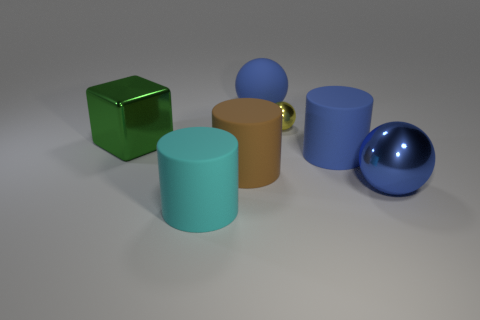Do the small shiny object and the shiny block have the same color?
Provide a succinct answer. No. The large matte object that is the same color as the large rubber sphere is what shape?
Offer a very short reply. Cylinder. What number of big blue metallic objects are the same shape as the cyan rubber object?
Your answer should be compact. 0. There is a green object that is made of the same material as the yellow sphere; what is its shape?
Provide a succinct answer. Cube. How many yellow things are either small matte cubes or big metallic things?
Keep it short and to the point. 0. Are there any large green shiny cubes behind the big shiny block?
Ensure brevity in your answer.  No. Do the shiny object in front of the green block and the blue object behind the big blue cylinder have the same shape?
Provide a succinct answer. Yes. There is a big cyan object that is the same shape as the big brown matte object; what is it made of?
Offer a terse response. Rubber. How many blocks are either green matte things or big brown rubber things?
Offer a terse response. 0. What number of large cyan things are the same material as the big green cube?
Your answer should be compact. 0. 